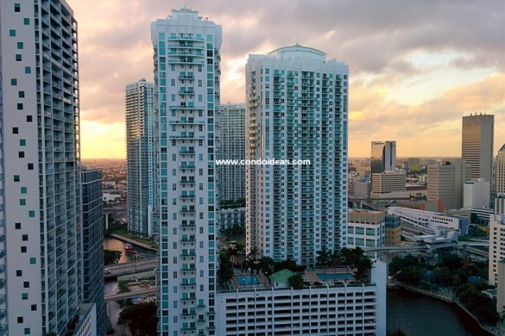Imagine a futuristic scenario involving these buildings. In the year 2050, these buildings have been transformed into self-sustaining vertical ecosystems. Each floor is dedicated to different functions — from residential spaces and hydroponic farms to renewable energy generators. Autonomous drones zip between towers, delivering goods and services. The river now powers advanced water filtration systems, ensuring a constant supply of clean water. Engaging holographic interfaces are embedded in the glass walls, connecting residents with their surroundings and each other seamlessly. Smart technology optimizes every aspect of urban living, making the city a paragon of futuristic innovation and ecological sustainability. What challenges might city planners face in managing such a densely populated urban area? Managing a densely populated urban area presents multiple challenges for city planners. Ensuring adequate infrastructure to support the growing population is paramount, including public transportation, waste management, and utilities. Planners also need to address environmental concerns, like reducing carbon emissions and increasing green spaces. The financial and logistical aspects of maintaining and upgrading aging buildings while integrating new technologies is another significant hurdle. Additionally, planners must consider social factors, such as providing affordable housing and preventing socioeconomic disparities. Balancing these needs requires innovative solutions and proactive policies to create a sustainable and livable urban environment. Describe a moment of serenity someone might find in this cityscape. Amidst the city's hustle, a moment of serenity can be found on the rooftop garden of one of these skyscrapers. It's an oasis of green, far removed from the noise below. As the sun begins to set, the garden is bathed in a warm, golden light. The gentle rustle of leaves is accompanied by the distant hum of city life. Sitting on a bench, a person might lose themselves in the view, watching the sky transform into a canvas of vibrant colors. It's a peaceful respite, a chance to breathe and reflect, suspended between the earth and the heavens. 